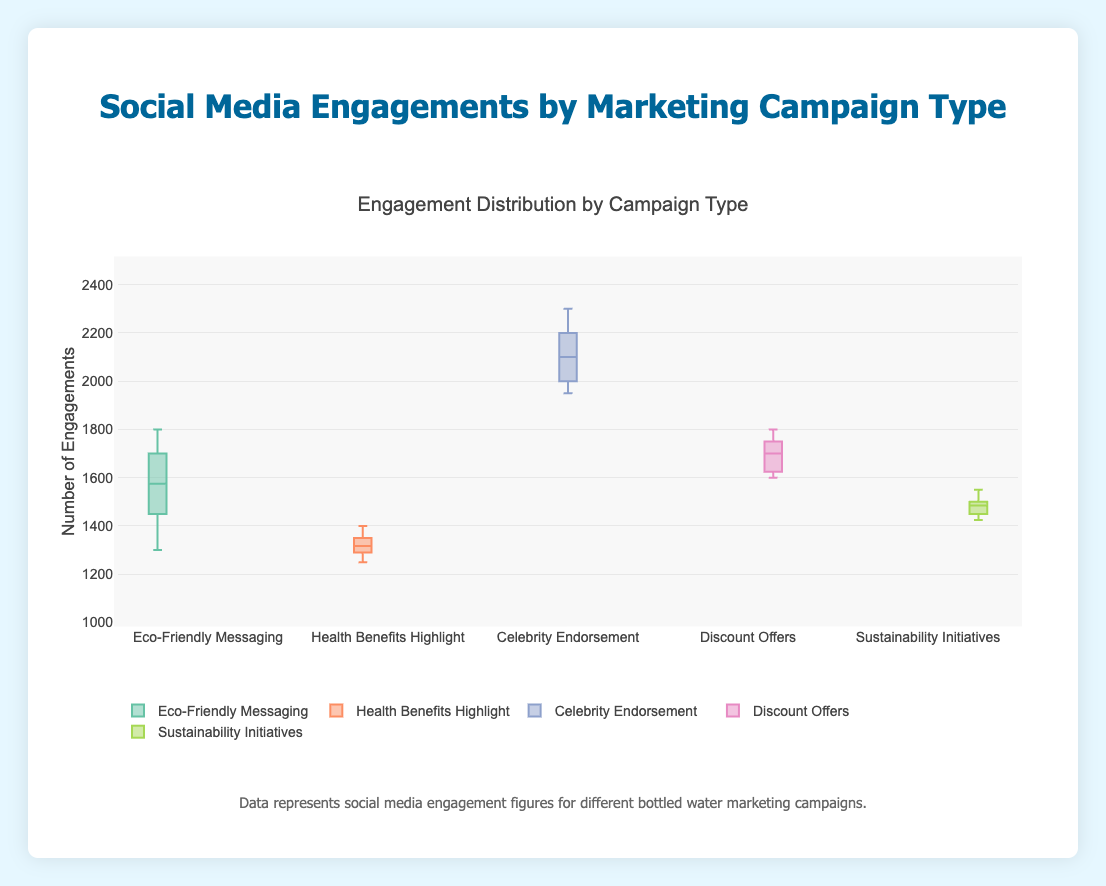How many marketing campaigns are represented in the figure? The title and the individual boxes represent different marketing campaigns. Count the number of boxes shown in the figure.
Answer: 5 Which marketing campaign has the highest median social media engagement? In a box plot, the median is represented by the line inside the box. Find the campaign with the highest line inside the box.
Answer: Celebrity Endorsement What is the interquartile range (IQR) for the "Discount Offers" campaign? The IQR is the distance between the first quartile (Q1) and the third quartile (Q3). Look at the "Discount Offers" box and calculate the difference between the top and bottom edges of the box.
Answer: 175 Which campaign has the smallest spread in social media engagement? The spread can be visually identified as the length of the box - the smaller the box, the smaller the spread. Compare the lengths of all boxes.
Answer: Health Benefits Highlight What are the outliers, if any, for the "Eco-Friendly Messaging" campaign? Outliers in a box plot are typically indicated by dots outside the whiskers. Check if there are any dots for "Eco-Friendly Messaging".
Answer: None Between "Sustainability Initiatives" and "Eco-Friendly Messaging", which campaign has the higher third quartile? The third quartile (Q3) is represented by the top edge of the box. Compare the top edges of these two campaigns.
Answer: Eco-Friendly Messaging How does the engagement range for "Celebrity Endorsement" compare to "Health Benefits Highlight"? The engagement range is the distance between the minimum and maximum values. Compare the lengths of the whiskers (extremities) for both campaigns.
Answer: Celebrity Endorsement has a wider range What is the median engagement value for the "Sustainability Initiatives" campaign? The median is indicated by the line inside the "Sustainability Initiatives" box. Identify where this line falls on the y-axis scale.
Answer: 1490 Which two campaigns have the closest median engagement values? Compare the positions of the median lines inside the boxes across all campaigns. Identify the two medians closest to each other.
Answer: Health Benefits Highlight and Sustainability Initiatives Is there more variability in engagement for "Eco-Friendly Messaging" or "Discount Offers"? Variability can be gauged by the size of the interquartile range (IQR) and the overall span of the whiskers. Compare the sizes of these features for both campaigns.
Answer: Eco-Friendly Messaging 